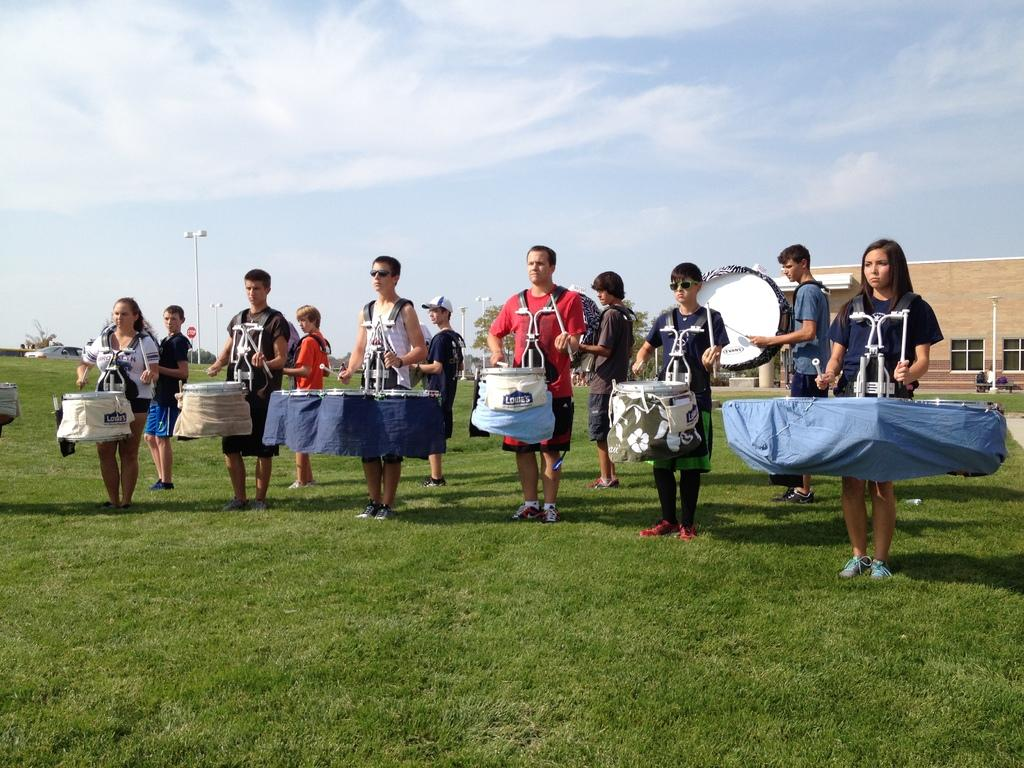What activity are the people in the image engaged in? The people in the image are playing drums. What type of structure can be seen in the image? There is a building in the image. What can be seen illuminating the scene in the image? There are lights visible in the image. What type of ground surface is present in the image? There is grass in the image. What is visible at the top of the image? The sky is visible at the top of the image, and there are clouds in the sky. What type of regret can be seen on the faces of the people playing drums in the image? There is no indication of regret on the faces of the people playing drums in the image. What type of yard is visible in the image? There is no yard visible in the image; the ground surface is grass. 